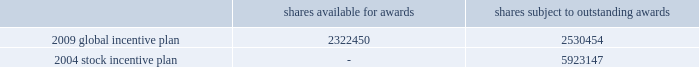Tax returns for 2001 and beyond are open for examination under statute .
Currently , unrecognized tax benefits are not expected to change significantly over the next 12 months .
19 .
Stock-based and other management compensation plans in april 2009 , the company approved a global incentive plan which replaces the company 2019s 2004 stock incentive plan .
The 2009 global incentive plan ( 201cgip 201d ) enables the compensation committee of the board of directors to award incentive and nonqualified stock options , stock appreciation rights , shares of series a common stock , restricted stock , restricted stock units ( 201crsus 201d ) and incentive bonuses ( which may be paid in cash or stock or a combination thereof ) , any of which may be performance-based , with vesting and other award provisions that provide effective incentive to company employees ( including officers ) , non-management directors and other service providers .
Under the 2009 gip , the company no longer can grant rsus with the right to participate in dividends or dividend equivalents .
The maximum number of shares that may be issued under the 2009 gip is equal to 5350000 shares plus ( a ) any shares of series a common stock that remain available for issuance under the 2004 stock incentive plan ( 201csip 201d ) ( not including any shares of series a common stock that are subject to outstanding awards under the 2004 sip or any shares of series a common stock that were issued pursuant to awards under the 2004 sip ) and ( b ) any awards under the 2004 stock incentive plan that remain outstanding that cease for any reason to be subject to such awards ( other than by reason of exercise or settlement of the award to the extent that such award is exercised for or settled in vested and non-forfeitable shares ) .
As of december 31 , 2010 , total shares available for awards and total shares subject to outstanding awards are as follows : shares available for awards shares subject to outstanding awards .
Upon the termination of a participant 2019s employment with the company by reason of death or disability or by the company without cause ( as defined in the respective award agreements ) , an award in amount equal to ( i ) the value of the award granted multiplied by ( ii ) a fraction , ( x ) the numerator of which is the number of full months between grant date and the date of such termination , and ( y ) the denominator of which is the term of the award , such product to be rounded down to the nearest whole number , and reduced by ( iii ) the value of any award that previously vested , shall immediately vest and become payable to the participant .
Upon the termination of a participant 2019s employment with the company for any other reason , any unvested portion of the award shall be forfeited and cancelled without consideration .
There was $ 19 million and $ 0 million of tax benefit realized from stock option exercises and vesting of rsus during the years ended december 31 , 2010 and 2009 , respectively .
During the year ended december 31 , 2008 the company reversed $ 8 million of the $ 19 million tax benefit that was realized during the year ended december 31 , 2007 .
Deferred compensation in april 2007 , certain participants in the company 2019s 2004 deferred compensation plan elected to participate in a revised program , which includes both cash awards and restricted stock units ( see restricted stock units below ) .
Based on participation in the revised program , the company expensed $ 9 million , $ 10 million and $ 8 million during the years ended december 31 , 2010 , 2009 and 2008 , respectively , related to the revised program and made payments of $ 4 million during the year ended december 31 , 2010 to participants who left the company and $ 28 million to active employees during december 2010 .
As of december 31 , 2010 , $ 1 million remains to be paid during 2011 under the revised program .
As of december 31 , 2009 , there was no deferred compensation payable remaining associated with the 2004 deferred compensation plan .
The company recorded expense related to participants continuing in the 2004 deferred %%transmsg*** transmitting job : d77691 pcn : 132000000 ***%%pcmsg|132 |00011|yes|no|02/09/2011 18:22|0|0|page is valid , no graphics -- color : n| .
In the 2009 global incentive plan what is the percent of the shares available to the shares subject to a outstanding awards? 
Rationale: the percent is the amount in question divide by the total
Computations: (2322450 / (2322450 + 2530454))
Answer: 0.47857. Tax returns for 2001 and beyond are open for examination under statute .
Currently , unrecognized tax benefits are not expected to change significantly over the next 12 months .
19 .
Stock-based and other management compensation plans in april 2009 , the company approved a global incentive plan which replaces the company 2019s 2004 stock incentive plan .
The 2009 global incentive plan ( 201cgip 201d ) enables the compensation committee of the board of directors to award incentive and nonqualified stock options , stock appreciation rights , shares of series a common stock , restricted stock , restricted stock units ( 201crsus 201d ) and incentive bonuses ( which may be paid in cash or stock or a combination thereof ) , any of which may be performance-based , with vesting and other award provisions that provide effective incentive to company employees ( including officers ) , non-management directors and other service providers .
Under the 2009 gip , the company no longer can grant rsus with the right to participate in dividends or dividend equivalents .
The maximum number of shares that may be issued under the 2009 gip is equal to 5350000 shares plus ( a ) any shares of series a common stock that remain available for issuance under the 2004 stock incentive plan ( 201csip 201d ) ( not including any shares of series a common stock that are subject to outstanding awards under the 2004 sip or any shares of series a common stock that were issued pursuant to awards under the 2004 sip ) and ( b ) any awards under the 2004 stock incentive plan that remain outstanding that cease for any reason to be subject to such awards ( other than by reason of exercise or settlement of the award to the extent that such award is exercised for or settled in vested and non-forfeitable shares ) .
As of december 31 , 2010 , total shares available for awards and total shares subject to outstanding awards are as follows : shares available for awards shares subject to outstanding awards .
Upon the termination of a participant 2019s employment with the company by reason of death or disability or by the company without cause ( as defined in the respective award agreements ) , an award in amount equal to ( i ) the value of the award granted multiplied by ( ii ) a fraction , ( x ) the numerator of which is the number of full months between grant date and the date of such termination , and ( y ) the denominator of which is the term of the award , such product to be rounded down to the nearest whole number , and reduced by ( iii ) the value of any award that previously vested , shall immediately vest and become payable to the participant .
Upon the termination of a participant 2019s employment with the company for any other reason , any unvested portion of the award shall be forfeited and cancelled without consideration .
There was $ 19 million and $ 0 million of tax benefit realized from stock option exercises and vesting of rsus during the years ended december 31 , 2010 and 2009 , respectively .
During the year ended december 31 , 2008 the company reversed $ 8 million of the $ 19 million tax benefit that was realized during the year ended december 31 , 2007 .
Deferred compensation in april 2007 , certain participants in the company 2019s 2004 deferred compensation plan elected to participate in a revised program , which includes both cash awards and restricted stock units ( see restricted stock units below ) .
Based on participation in the revised program , the company expensed $ 9 million , $ 10 million and $ 8 million during the years ended december 31 , 2010 , 2009 and 2008 , respectively , related to the revised program and made payments of $ 4 million during the year ended december 31 , 2010 to participants who left the company and $ 28 million to active employees during december 2010 .
As of december 31 , 2010 , $ 1 million remains to be paid during 2011 under the revised program .
As of december 31 , 2009 , there was no deferred compensation payable remaining associated with the 2004 deferred compensation plan .
The company recorded expense related to participants continuing in the 2004 deferred %%transmsg*** transmitting job : d77691 pcn : 132000000 ***%%pcmsg|132 |00011|yes|no|02/09/2011 18:22|0|0|page is valid , no graphics -- color : n| .
What is the total number of shares subject to outstanding awards from both 2004 and 2009? 
Rationale: the total number is the sum of all the amounts
Computations: (5923147 + 2530454)
Answer: 8453601.0. 